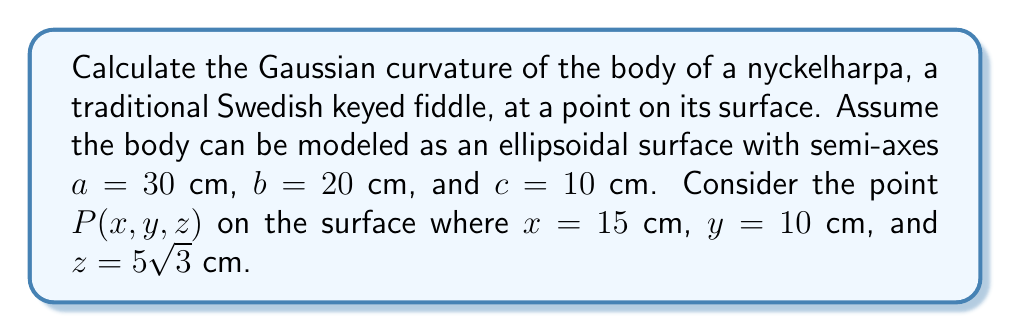Solve this math problem. To calculate the Gaussian curvature of the nyckelharpa's body at point P, we'll follow these steps:

1) The equation of an ellipsoid is given by:

   $$\frac{x^2}{a^2} + \frac{y^2}{b^2} + \frac{z^2}{c^2} = 1$$

2) We can parametrize the surface using spherical coordinates:

   $$x = a \sin\theta \cos\phi$$
   $$y = b \sin\theta \sin\phi$$
   $$z = c \cos\theta$$

3) The first fundamental form coefficients are:

   $$E = a^2\cos^2\phi\cos^2\theta + b^2\sin^2\phi\cos^2\theta + c^2\sin^2\theta$$
   $$F = (b^2 - a^2)\sin\phi\cos\phi\cos\theta$$
   $$G = a^2\sin^2\phi + b^2\cos^2\phi$$

4) The second fundamental form coefficients are:

   $$L = \frac{abc}{\sqrt{E G - F^2}}$$
   $$M = 0$$
   $$N = \frac{abc\sin\theta}{\sqrt{E G - F^2}}$$

5) The Gaussian curvature K is given by:

   $$K = \frac{LN - M^2}{EG - F^2}$$

6) Substituting the values at point P:

   $$\sin\theta = \frac{\sqrt{x^2 + y^2}}{r} = \frac{\sqrt{15^2 + 10^2}}{\sqrt{15^2 + 10^2 + (5\sqrt{3})^2}} = \frac{\sqrt{325}}{30}$$
   $$\cos\theta = \frac{z}{c} = \frac{5\sqrt{3}}{10} = \frac{\sqrt{75}}{10}$$
   $$\cos\phi = \frac{x}{a\sin\theta} = \frac{15}{30} \cdot \frac{30}{\sqrt{325}} = \frac{15}{\sqrt{325}}$$
   $$\sin\phi = \frac{y}{b\sin\theta} = \frac{10}{20} \cdot \frac{30}{\sqrt{325}} = \frac{15}{\sqrt{325}}$$

7) Calculating E, G, and F:

   $$E = 900 \cdot \frac{225}{325} + 400 \cdot \frac{225}{325} + 100 \cdot \frac{75}{100} = 675$$
   $$F = (400 - 900) \cdot \frac{225}{325} \cdot \frac{15}{\sqrt{325}} \cdot \frac{\sqrt{75}}{10} = -225\sqrt{3}$$
   $$G = 900 \cdot \frac{225}{325} + 400 \cdot \frac{100}{325} = 800$$

8) Calculating L and N:

   $$L = N = \frac{6000}{\sqrt{675 \cdot 800 - (-225\sqrt{3})^2}} = \frac{20}{\sqrt{3}}$$

9) Finally, calculating K:

   $$K = \frac{(\frac{20}{\sqrt{3}})^2 - 0^2}{675 \cdot 800 - (-225\sqrt{3})^2} = \frac{400}{3} \cdot \frac{1}{540000 - 151875} = \frac{1}{1035}$$
Answer: $\frac{1}{1035}$ cm^(-2) 